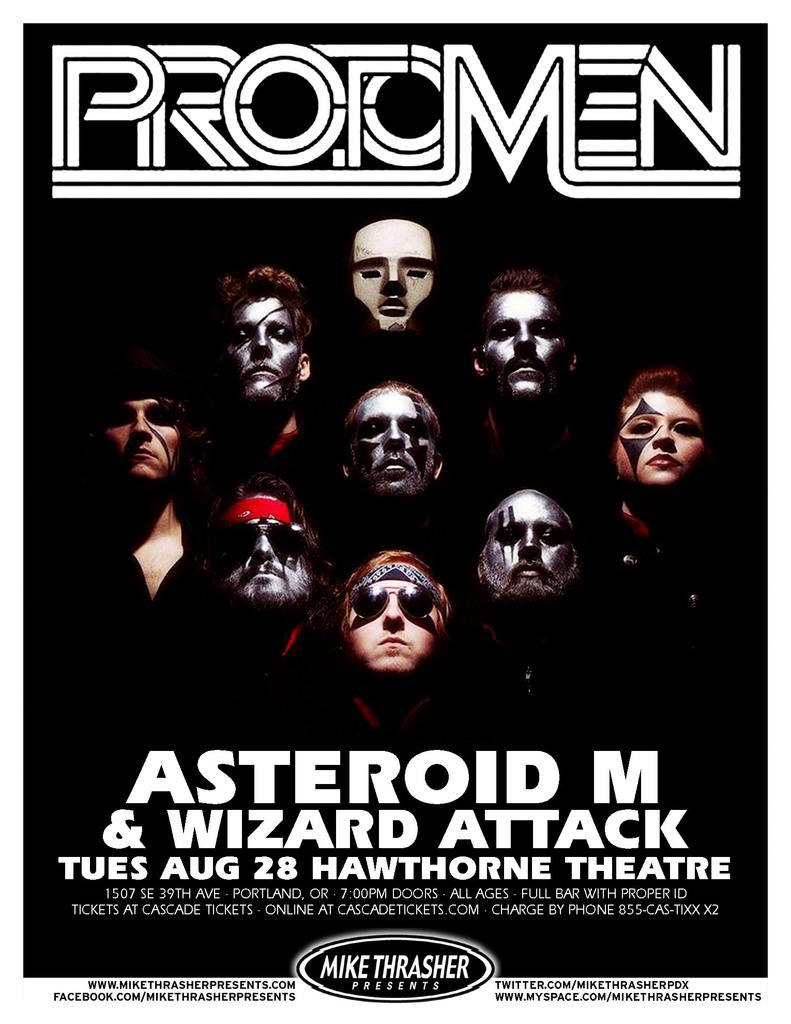<image>
Render a clear and concise summary of the photo. A poster that is for protomen and has the faces of them on it. 